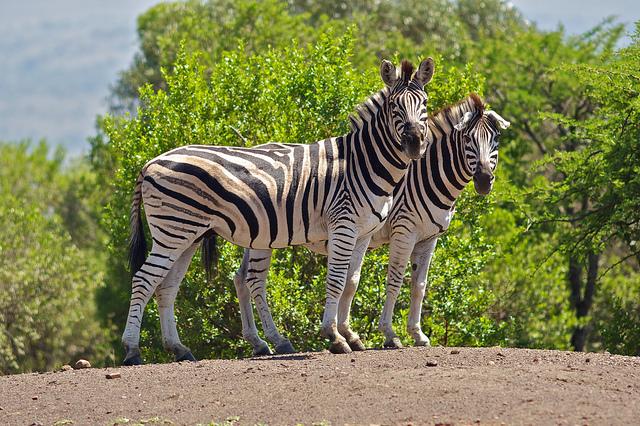Are the zebras in their natural habitat?
Concise answer only. Yes. How many zebras are there?
Short answer required. 2. How many zebras are in the picture?
Write a very short answer. 2. Is this area desert-like or lush and green?
Quick response, please. Lush and green. Are the animals striped?
Concise answer only. Yes. What are the zebras doing?
Short answer required. Standing. Is this picture in full color?
Short answer required. Yes. 